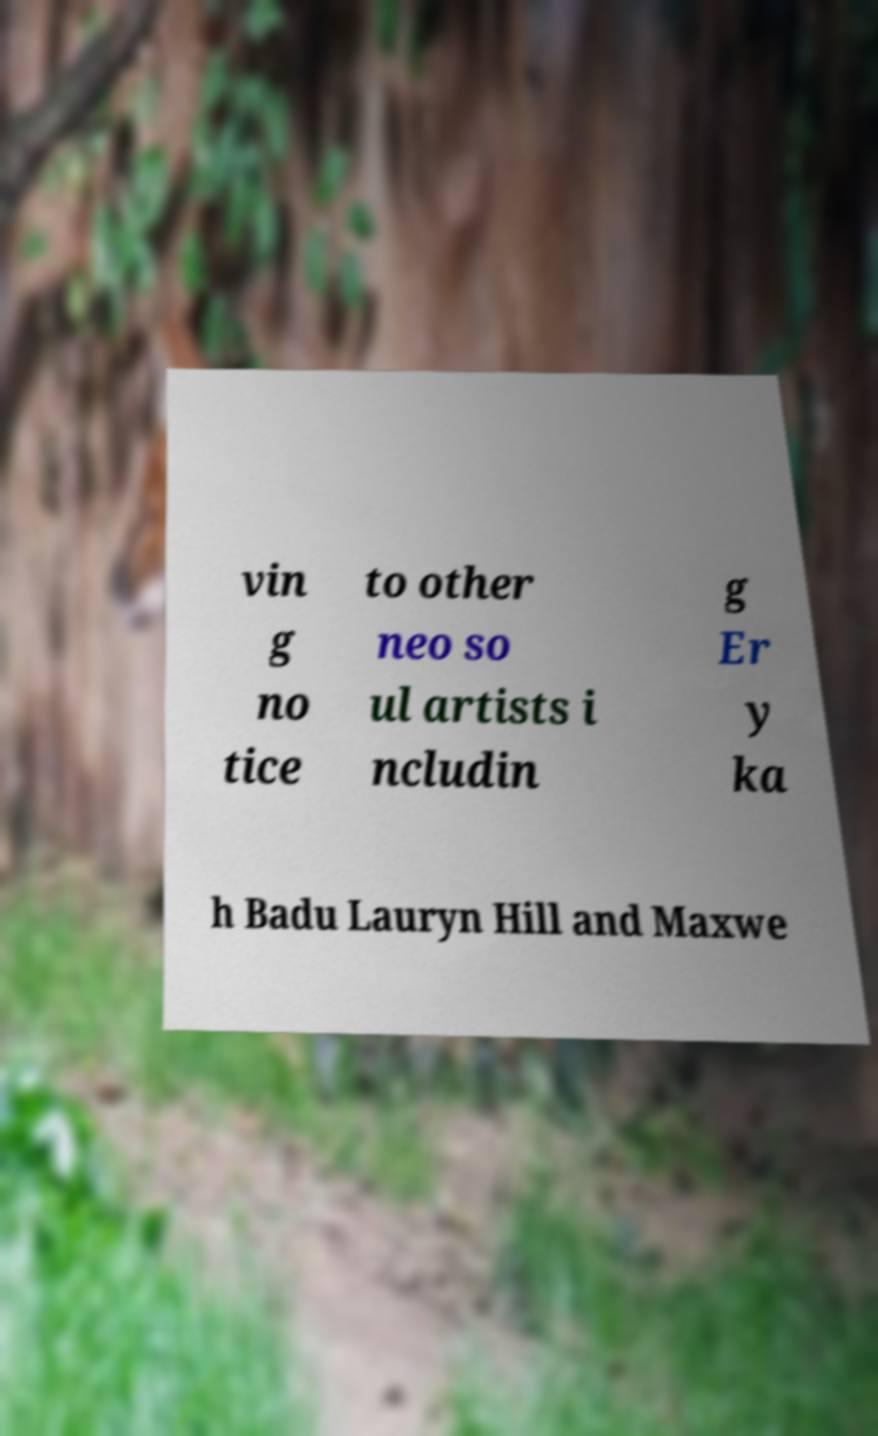There's text embedded in this image that I need extracted. Can you transcribe it verbatim? vin g no tice to other neo so ul artists i ncludin g Er y ka h Badu Lauryn Hill and Maxwe 